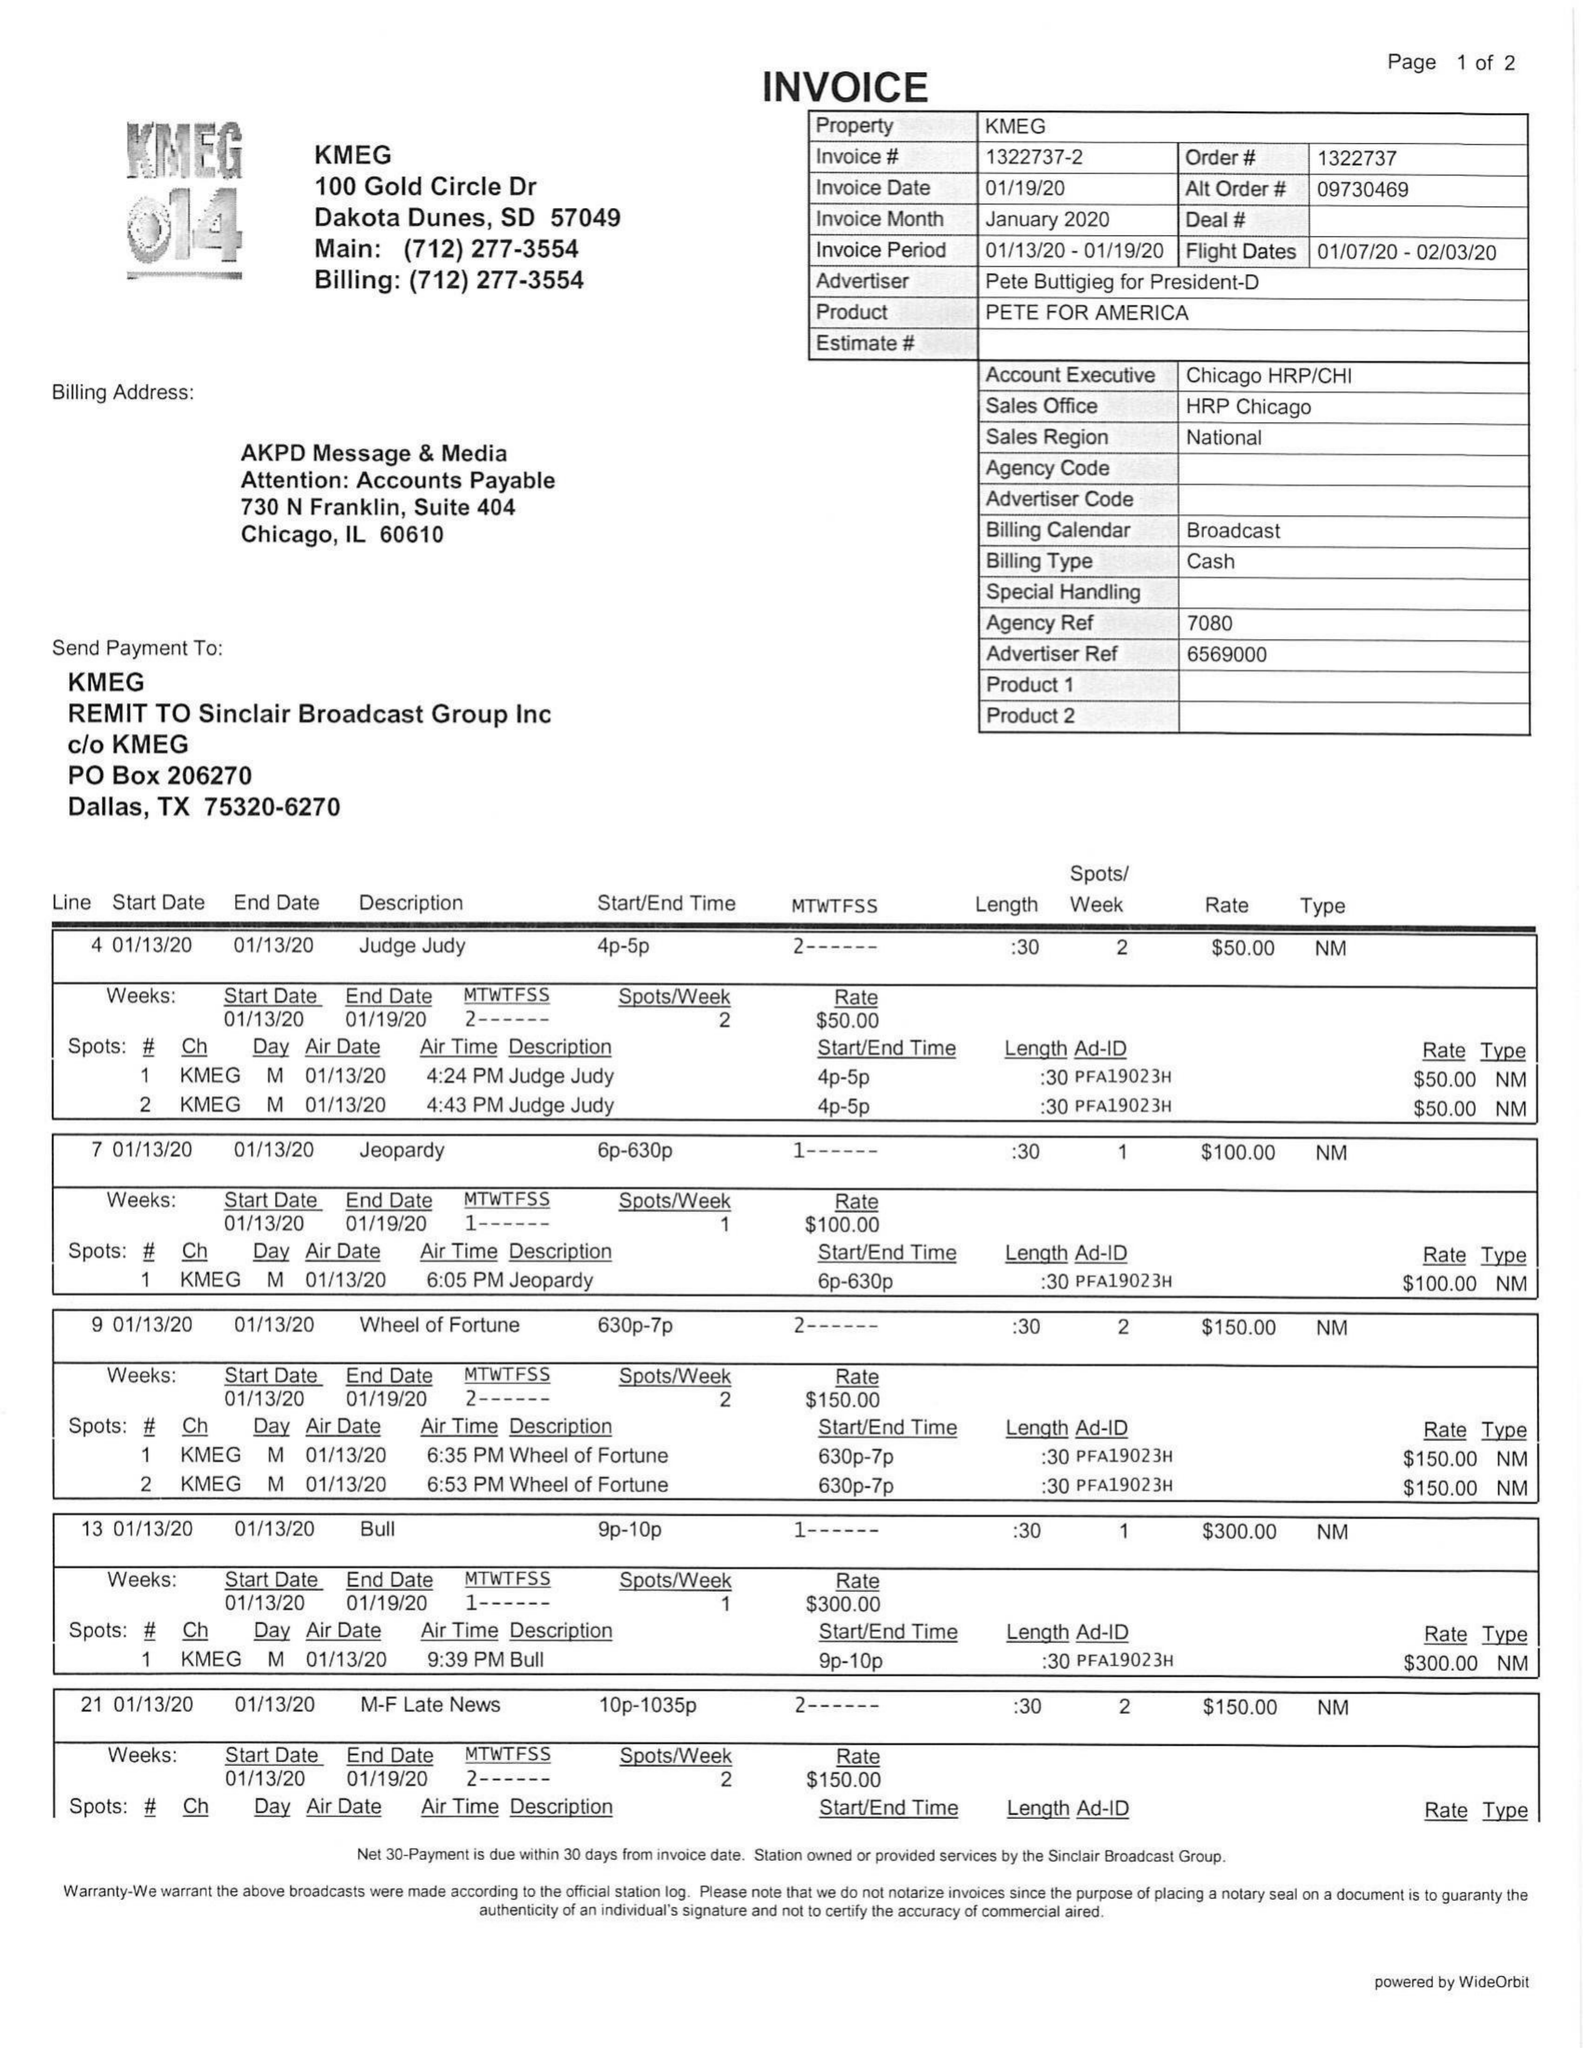What is the value for the flight_from?
Answer the question using a single word or phrase. 01/07/20 